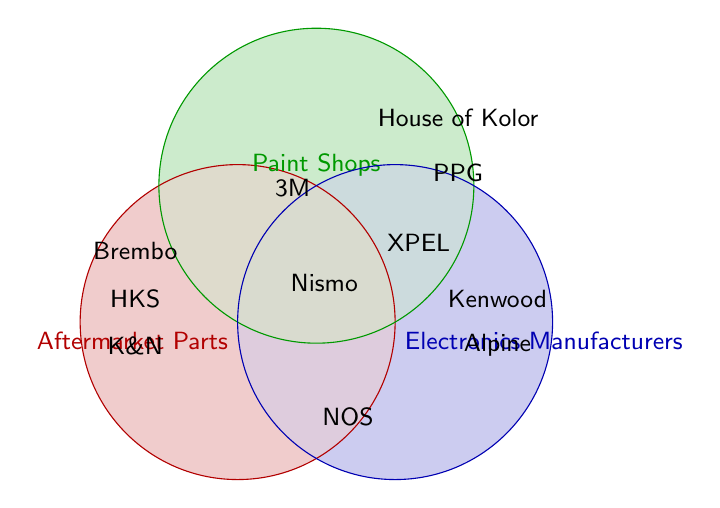What are the names of the suppliers exclusively for Aftermarket Parts? The red circle represents Aftermarket Parts. The names inside only this circle are K&N Filters, HKS Turbochargers, and Brembo Brakes.
Answer: K&N Filters, HKS Turbochargers, Brembo Brakes Which supplier is common to all three categories? The overlapping area of all three circles (Aftermarket Parts, Paint Shops, and Electronics Manufacturers) identifies the common supplier, which is labeled as Nismo Performance.
Answer: Nismo Performance How many suppliers are there exclusively in the Paint Shops category? Look at the labels inside the green circle representing Paint Shops and not overlapping with the other circles. There are two such labels: House of Kolor and PPG Automotive Refinish.
Answer: Two Which suppliers are common between Aftermarket Parts and Electronics Manufacturers but not involved in Paint Shops? The overlapping area between the red and blue circles (Aftermarket Parts and Electronics Manufacturers) but not the green (Paint Shops) shows NOS Nitrous Systems.
Answer: NOS Nitrous Systems Are there more suppliers that interact with Electronics Manufacturers compared to Paint Shops? Count the labels: Electronics Manufacturers (Alpine Audio, Kenwood) plus intersections involving Electronics Manufacturers (XPEL, Nismo Performance, NOS Nitrous Systems), totaling 5. Paint Shops (House of Kolor, PPG Automotive Refinish) plus intersections involving Paint Shops (3M Automotive, XPEL, Nismo Performance), totaling 5. Both categories have equal numbers of supplier interactions.
Answer: No How many suppliers are common between Paint Shops and Electronics Manufacturers? The intersection area between green and blue circles shows XPEL Paint Protection and includes Nismo Performance, totaling 2 common suppliers.
Answer: Two Which category has the least exclusive suppliers? Count exclusive suppliers in each category: Aftermarket Parts (3), Paint Shops (2), Electronics Manufacturers (2). Paint Shops and Electronics Manufacturers both have the least with 2 suppliers each.
Answer: Paint Shops and Electronics Manufacturers What is the name of the supplier that serves both Aftermarket Parts and Paint Shops but no other categories? The area of intersection between the red and green circles, but excluding the blue, shows the label for 3M Automotive.
Answer: 3M Automotive 